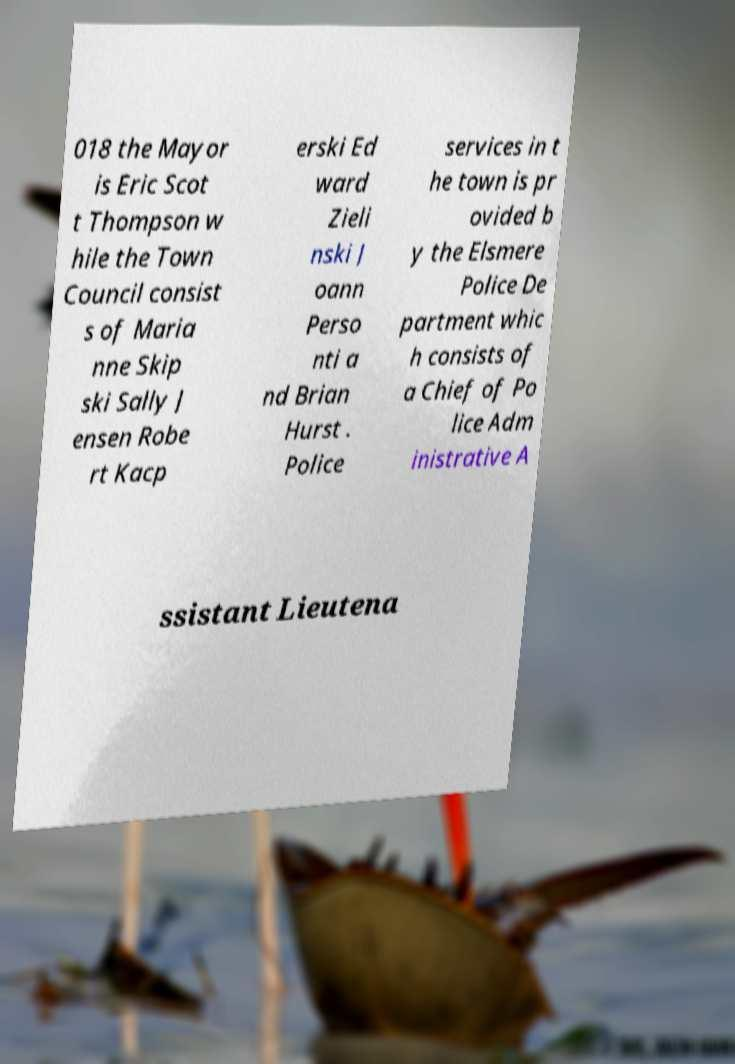Please read and relay the text visible in this image. What does it say? 018 the Mayor is Eric Scot t Thompson w hile the Town Council consist s of Maria nne Skip ski Sally J ensen Robe rt Kacp erski Ed ward Zieli nski J oann Perso nti a nd Brian Hurst . Police services in t he town is pr ovided b y the Elsmere Police De partment whic h consists of a Chief of Po lice Adm inistrative A ssistant Lieutena 